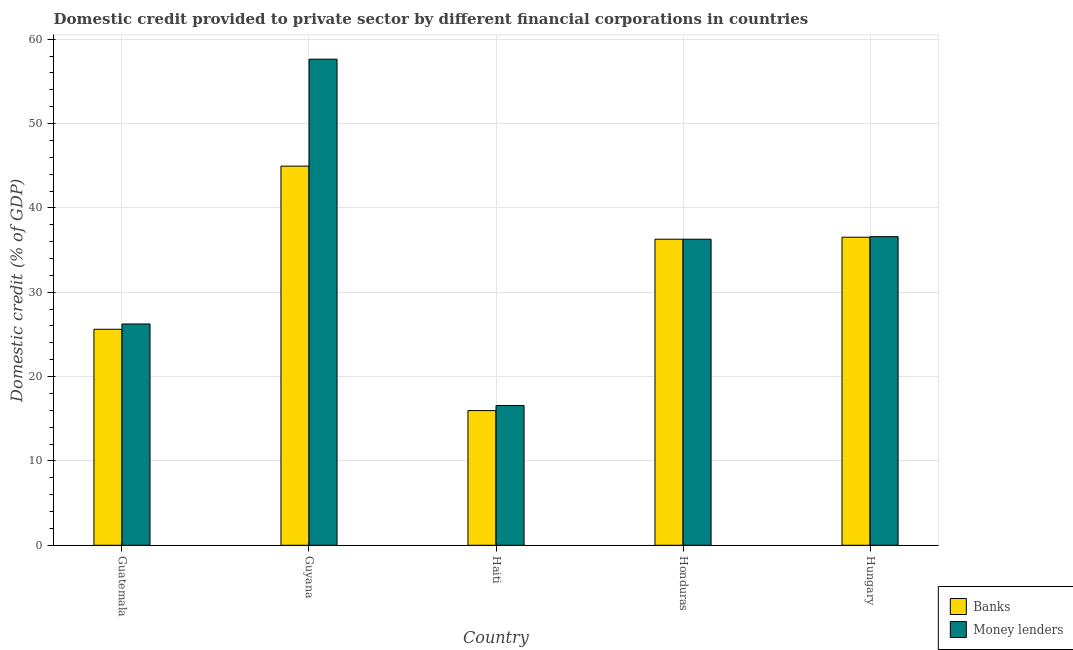How many different coloured bars are there?
Give a very brief answer. 2. How many groups of bars are there?
Ensure brevity in your answer.  5. Are the number of bars on each tick of the X-axis equal?
Your response must be concise. Yes. What is the label of the 1st group of bars from the left?
Make the answer very short. Guatemala. In how many cases, is the number of bars for a given country not equal to the number of legend labels?
Ensure brevity in your answer.  0. What is the domestic credit provided by banks in Hungary?
Your response must be concise. 36.52. Across all countries, what is the maximum domestic credit provided by banks?
Provide a short and direct response. 44.96. Across all countries, what is the minimum domestic credit provided by banks?
Provide a short and direct response. 15.97. In which country was the domestic credit provided by banks maximum?
Provide a succinct answer. Guyana. In which country was the domestic credit provided by money lenders minimum?
Your answer should be very brief. Haiti. What is the total domestic credit provided by banks in the graph?
Your response must be concise. 159.35. What is the difference between the domestic credit provided by banks in Guyana and that in Haiti?
Make the answer very short. 28.99. What is the difference between the domestic credit provided by banks in Guyana and the domestic credit provided by money lenders in Haiti?
Offer a very short reply. 28.38. What is the average domestic credit provided by banks per country?
Your answer should be very brief. 31.87. In how many countries, is the domestic credit provided by money lenders greater than 42 %?
Keep it short and to the point. 1. What is the ratio of the domestic credit provided by banks in Honduras to that in Hungary?
Your answer should be compact. 0.99. Is the domestic credit provided by money lenders in Guatemala less than that in Guyana?
Offer a terse response. Yes. Is the difference between the domestic credit provided by banks in Haiti and Honduras greater than the difference between the domestic credit provided by money lenders in Haiti and Honduras?
Your answer should be compact. No. What is the difference between the highest and the second highest domestic credit provided by money lenders?
Keep it short and to the point. 21.04. What is the difference between the highest and the lowest domestic credit provided by money lenders?
Your response must be concise. 41.06. In how many countries, is the domestic credit provided by money lenders greater than the average domestic credit provided by money lenders taken over all countries?
Provide a succinct answer. 3. What does the 1st bar from the left in Guyana represents?
Ensure brevity in your answer.  Banks. What does the 1st bar from the right in Hungary represents?
Your response must be concise. Money lenders. What is the difference between two consecutive major ticks on the Y-axis?
Offer a terse response. 10. Are the values on the major ticks of Y-axis written in scientific E-notation?
Give a very brief answer. No. Does the graph contain any zero values?
Your answer should be very brief. No. Where does the legend appear in the graph?
Keep it short and to the point. Bottom right. What is the title of the graph?
Your answer should be compact. Domestic credit provided to private sector by different financial corporations in countries. Does "Domestic Liabilities" appear as one of the legend labels in the graph?
Your answer should be very brief. No. What is the label or title of the Y-axis?
Keep it short and to the point. Domestic credit (% of GDP). What is the Domestic credit (% of GDP) of Banks in Guatemala?
Provide a succinct answer. 25.61. What is the Domestic credit (% of GDP) in Money lenders in Guatemala?
Offer a terse response. 26.24. What is the Domestic credit (% of GDP) in Banks in Guyana?
Your answer should be very brief. 44.96. What is the Domestic credit (% of GDP) in Money lenders in Guyana?
Offer a very short reply. 57.64. What is the Domestic credit (% of GDP) in Banks in Haiti?
Provide a succinct answer. 15.97. What is the Domestic credit (% of GDP) of Money lenders in Haiti?
Provide a succinct answer. 16.57. What is the Domestic credit (% of GDP) in Banks in Honduras?
Keep it short and to the point. 36.29. What is the Domestic credit (% of GDP) of Money lenders in Honduras?
Your answer should be very brief. 36.29. What is the Domestic credit (% of GDP) in Banks in Hungary?
Your response must be concise. 36.52. What is the Domestic credit (% of GDP) of Money lenders in Hungary?
Your response must be concise. 36.59. Across all countries, what is the maximum Domestic credit (% of GDP) in Banks?
Ensure brevity in your answer.  44.96. Across all countries, what is the maximum Domestic credit (% of GDP) in Money lenders?
Offer a very short reply. 57.64. Across all countries, what is the minimum Domestic credit (% of GDP) of Banks?
Ensure brevity in your answer.  15.97. Across all countries, what is the minimum Domestic credit (% of GDP) in Money lenders?
Your answer should be compact. 16.57. What is the total Domestic credit (% of GDP) of Banks in the graph?
Offer a very short reply. 159.35. What is the total Domestic credit (% of GDP) of Money lenders in the graph?
Make the answer very short. 173.33. What is the difference between the Domestic credit (% of GDP) in Banks in Guatemala and that in Guyana?
Give a very brief answer. -19.34. What is the difference between the Domestic credit (% of GDP) in Money lenders in Guatemala and that in Guyana?
Make the answer very short. -31.4. What is the difference between the Domestic credit (% of GDP) in Banks in Guatemala and that in Haiti?
Your response must be concise. 9.64. What is the difference between the Domestic credit (% of GDP) of Money lenders in Guatemala and that in Haiti?
Make the answer very short. 9.66. What is the difference between the Domestic credit (% of GDP) of Banks in Guatemala and that in Honduras?
Make the answer very short. -10.68. What is the difference between the Domestic credit (% of GDP) of Money lenders in Guatemala and that in Honduras?
Offer a terse response. -10.05. What is the difference between the Domestic credit (% of GDP) of Banks in Guatemala and that in Hungary?
Offer a terse response. -10.91. What is the difference between the Domestic credit (% of GDP) of Money lenders in Guatemala and that in Hungary?
Give a very brief answer. -10.35. What is the difference between the Domestic credit (% of GDP) of Banks in Guyana and that in Haiti?
Keep it short and to the point. 28.99. What is the difference between the Domestic credit (% of GDP) of Money lenders in Guyana and that in Haiti?
Your response must be concise. 41.06. What is the difference between the Domestic credit (% of GDP) in Banks in Guyana and that in Honduras?
Offer a very short reply. 8.66. What is the difference between the Domestic credit (% of GDP) of Money lenders in Guyana and that in Honduras?
Provide a succinct answer. 21.35. What is the difference between the Domestic credit (% of GDP) in Banks in Guyana and that in Hungary?
Your response must be concise. 8.43. What is the difference between the Domestic credit (% of GDP) of Money lenders in Guyana and that in Hungary?
Give a very brief answer. 21.04. What is the difference between the Domestic credit (% of GDP) in Banks in Haiti and that in Honduras?
Offer a terse response. -20.32. What is the difference between the Domestic credit (% of GDP) of Money lenders in Haiti and that in Honduras?
Offer a very short reply. -19.72. What is the difference between the Domestic credit (% of GDP) of Banks in Haiti and that in Hungary?
Keep it short and to the point. -20.56. What is the difference between the Domestic credit (% of GDP) in Money lenders in Haiti and that in Hungary?
Offer a very short reply. -20.02. What is the difference between the Domestic credit (% of GDP) in Banks in Honduras and that in Hungary?
Provide a succinct answer. -0.23. What is the difference between the Domestic credit (% of GDP) in Money lenders in Honduras and that in Hungary?
Offer a terse response. -0.3. What is the difference between the Domestic credit (% of GDP) in Banks in Guatemala and the Domestic credit (% of GDP) in Money lenders in Guyana?
Keep it short and to the point. -32.02. What is the difference between the Domestic credit (% of GDP) of Banks in Guatemala and the Domestic credit (% of GDP) of Money lenders in Haiti?
Ensure brevity in your answer.  9.04. What is the difference between the Domestic credit (% of GDP) in Banks in Guatemala and the Domestic credit (% of GDP) in Money lenders in Honduras?
Offer a terse response. -10.68. What is the difference between the Domestic credit (% of GDP) of Banks in Guatemala and the Domestic credit (% of GDP) of Money lenders in Hungary?
Give a very brief answer. -10.98. What is the difference between the Domestic credit (% of GDP) of Banks in Guyana and the Domestic credit (% of GDP) of Money lenders in Haiti?
Ensure brevity in your answer.  28.38. What is the difference between the Domestic credit (% of GDP) in Banks in Guyana and the Domestic credit (% of GDP) in Money lenders in Honduras?
Give a very brief answer. 8.66. What is the difference between the Domestic credit (% of GDP) in Banks in Guyana and the Domestic credit (% of GDP) in Money lenders in Hungary?
Provide a short and direct response. 8.36. What is the difference between the Domestic credit (% of GDP) in Banks in Haiti and the Domestic credit (% of GDP) in Money lenders in Honduras?
Ensure brevity in your answer.  -20.32. What is the difference between the Domestic credit (% of GDP) of Banks in Haiti and the Domestic credit (% of GDP) of Money lenders in Hungary?
Keep it short and to the point. -20.62. What is the difference between the Domestic credit (% of GDP) in Banks in Honduras and the Domestic credit (% of GDP) in Money lenders in Hungary?
Keep it short and to the point. -0.3. What is the average Domestic credit (% of GDP) in Banks per country?
Give a very brief answer. 31.87. What is the average Domestic credit (% of GDP) of Money lenders per country?
Offer a very short reply. 34.67. What is the difference between the Domestic credit (% of GDP) of Banks and Domestic credit (% of GDP) of Money lenders in Guatemala?
Give a very brief answer. -0.63. What is the difference between the Domestic credit (% of GDP) in Banks and Domestic credit (% of GDP) in Money lenders in Guyana?
Give a very brief answer. -12.68. What is the difference between the Domestic credit (% of GDP) in Banks and Domestic credit (% of GDP) in Money lenders in Haiti?
Your answer should be very brief. -0.61. What is the difference between the Domestic credit (% of GDP) in Banks and Domestic credit (% of GDP) in Money lenders in Honduras?
Offer a terse response. 0. What is the difference between the Domestic credit (% of GDP) in Banks and Domestic credit (% of GDP) in Money lenders in Hungary?
Ensure brevity in your answer.  -0.07. What is the ratio of the Domestic credit (% of GDP) of Banks in Guatemala to that in Guyana?
Offer a terse response. 0.57. What is the ratio of the Domestic credit (% of GDP) in Money lenders in Guatemala to that in Guyana?
Your answer should be very brief. 0.46. What is the ratio of the Domestic credit (% of GDP) in Banks in Guatemala to that in Haiti?
Your response must be concise. 1.6. What is the ratio of the Domestic credit (% of GDP) of Money lenders in Guatemala to that in Haiti?
Keep it short and to the point. 1.58. What is the ratio of the Domestic credit (% of GDP) in Banks in Guatemala to that in Honduras?
Your answer should be compact. 0.71. What is the ratio of the Domestic credit (% of GDP) in Money lenders in Guatemala to that in Honduras?
Give a very brief answer. 0.72. What is the ratio of the Domestic credit (% of GDP) of Banks in Guatemala to that in Hungary?
Your answer should be compact. 0.7. What is the ratio of the Domestic credit (% of GDP) of Money lenders in Guatemala to that in Hungary?
Provide a succinct answer. 0.72. What is the ratio of the Domestic credit (% of GDP) in Banks in Guyana to that in Haiti?
Your answer should be very brief. 2.82. What is the ratio of the Domestic credit (% of GDP) in Money lenders in Guyana to that in Haiti?
Offer a very short reply. 3.48. What is the ratio of the Domestic credit (% of GDP) in Banks in Guyana to that in Honduras?
Offer a very short reply. 1.24. What is the ratio of the Domestic credit (% of GDP) of Money lenders in Guyana to that in Honduras?
Your response must be concise. 1.59. What is the ratio of the Domestic credit (% of GDP) in Banks in Guyana to that in Hungary?
Make the answer very short. 1.23. What is the ratio of the Domestic credit (% of GDP) of Money lenders in Guyana to that in Hungary?
Make the answer very short. 1.58. What is the ratio of the Domestic credit (% of GDP) in Banks in Haiti to that in Honduras?
Your answer should be very brief. 0.44. What is the ratio of the Domestic credit (% of GDP) of Money lenders in Haiti to that in Honduras?
Your response must be concise. 0.46. What is the ratio of the Domestic credit (% of GDP) in Banks in Haiti to that in Hungary?
Give a very brief answer. 0.44. What is the ratio of the Domestic credit (% of GDP) in Money lenders in Haiti to that in Hungary?
Your response must be concise. 0.45. What is the ratio of the Domestic credit (% of GDP) in Money lenders in Honduras to that in Hungary?
Your response must be concise. 0.99. What is the difference between the highest and the second highest Domestic credit (% of GDP) of Banks?
Provide a short and direct response. 8.43. What is the difference between the highest and the second highest Domestic credit (% of GDP) in Money lenders?
Give a very brief answer. 21.04. What is the difference between the highest and the lowest Domestic credit (% of GDP) of Banks?
Offer a terse response. 28.99. What is the difference between the highest and the lowest Domestic credit (% of GDP) of Money lenders?
Make the answer very short. 41.06. 